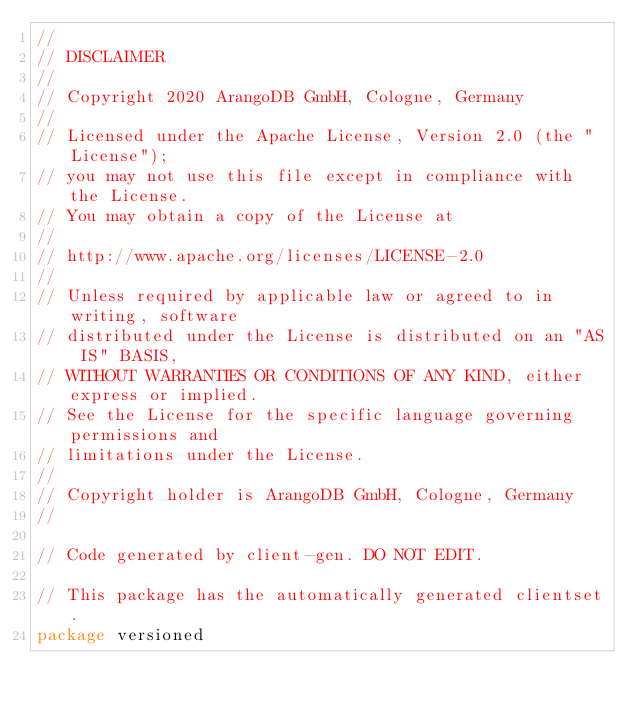<code> <loc_0><loc_0><loc_500><loc_500><_Go_>//
// DISCLAIMER
//
// Copyright 2020 ArangoDB GmbH, Cologne, Germany
//
// Licensed under the Apache License, Version 2.0 (the "License");
// you may not use this file except in compliance with the License.
// You may obtain a copy of the License at
//
// http://www.apache.org/licenses/LICENSE-2.0
//
// Unless required by applicable law or agreed to in writing, software
// distributed under the License is distributed on an "AS IS" BASIS,
// WITHOUT WARRANTIES OR CONDITIONS OF ANY KIND, either express or implied.
// See the License for the specific language governing permissions and
// limitations under the License.
//
// Copyright holder is ArangoDB GmbH, Cologne, Germany
//

// Code generated by client-gen. DO NOT EDIT.

// This package has the automatically generated clientset.
package versioned
</code> 